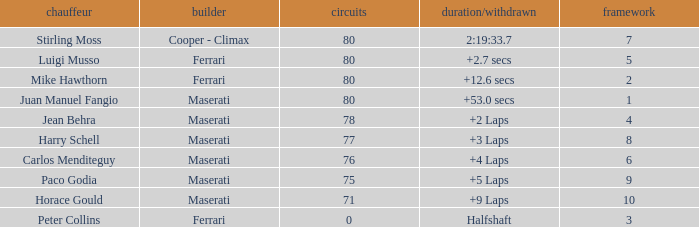What were the lowest laps of Luigi Musso driving a Ferrari with a Grid larger than 2? 80.0. 